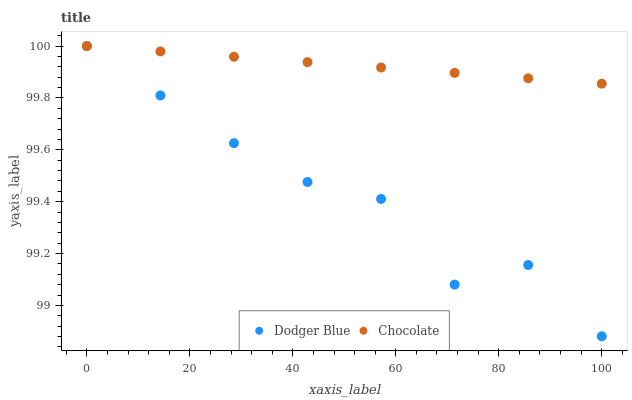Does Dodger Blue have the minimum area under the curve?
Answer yes or no. Yes. Does Chocolate have the maximum area under the curve?
Answer yes or no. Yes. Does Chocolate have the minimum area under the curve?
Answer yes or no. No. Is Chocolate the smoothest?
Answer yes or no. Yes. Is Dodger Blue the roughest?
Answer yes or no. Yes. Is Chocolate the roughest?
Answer yes or no. No. Does Dodger Blue have the lowest value?
Answer yes or no. Yes. Does Chocolate have the lowest value?
Answer yes or no. No. Does Chocolate have the highest value?
Answer yes or no. Yes. Does Chocolate intersect Dodger Blue?
Answer yes or no. Yes. Is Chocolate less than Dodger Blue?
Answer yes or no. No. Is Chocolate greater than Dodger Blue?
Answer yes or no. No. 